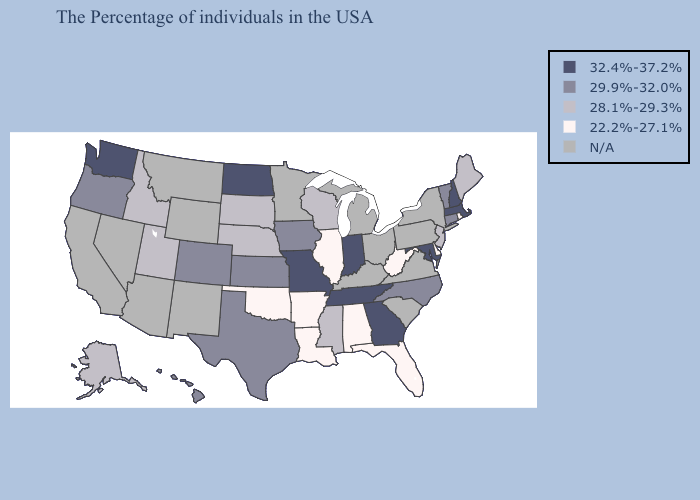Does Washington have the lowest value in the USA?
Give a very brief answer. No. Which states hav the highest value in the Northeast?
Short answer required. Massachusetts, New Hampshire. Which states have the highest value in the USA?
Give a very brief answer. Massachusetts, New Hampshire, Maryland, Georgia, Indiana, Tennessee, Missouri, North Dakota, Washington. Does South Dakota have the highest value in the MidWest?
Keep it brief. No. Name the states that have a value in the range 28.1%-29.3%?
Write a very short answer. Maine, New Jersey, Wisconsin, Mississippi, Nebraska, South Dakota, Utah, Idaho, Alaska. Name the states that have a value in the range 32.4%-37.2%?
Quick response, please. Massachusetts, New Hampshire, Maryland, Georgia, Indiana, Tennessee, Missouri, North Dakota, Washington. Name the states that have a value in the range 22.2%-27.1%?
Keep it brief. Rhode Island, Delaware, West Virginia, Florida, Alabama, Illinois, Louisiana, Arkansas, Oklahoma. Name the states that have a value in the range N/A?
Answer briefly. New York, Pennsylvania, Virginia, South Carolina, Ohio, Michigan, Kentucky, Minnesota, Wyoming, New Mexico, Montana, Arizona, Nevada, California. Is the legend a continuous bar?
Keep it brief. No. Among the states that border North Dakota , which have the lowest value?
Concise answer only. South Dakota. Name the states that have a value in the range 22.2%-27.1%?
Concise answer only. Rhode Island, Delaware, West Virginia, Florida, Alabama, Illinois, Louisiana, Arkansas, Oklahoma. What is the value of Illinois?
Concise answer only. 22.2%-27.1%. Name the states that have a value in the range 32.4%-37.2%?
Quick response, please. Massachusetts, New Hampshire, Maryland, Georgia, Indiana, Tennessee, Missouri, North Dakota, Washington. How many symbols are there in the legend?
Give a very brief answer. 5. Does Rhode Island have the lowest value in the Northeast?
Keep it brief. Yes. 